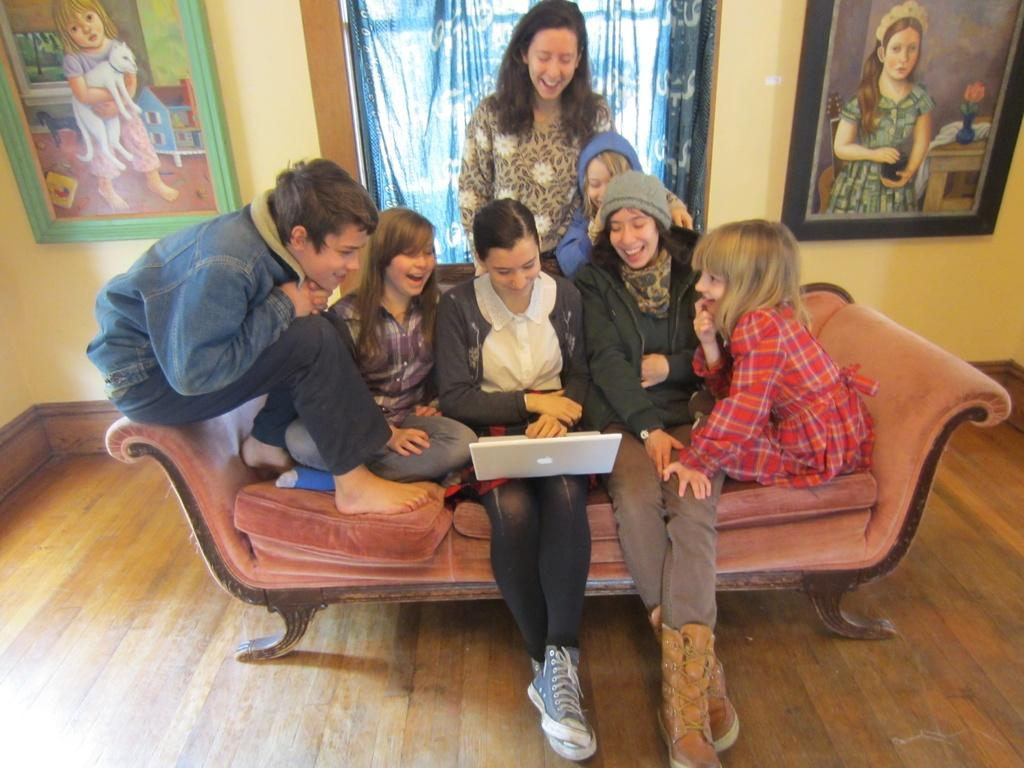Who or what is the focus of the people in the image? The people in the image are looking towards a laptop. What can be seen in the background of the image? There is a window and photo frames in the background of the image. What type of pen is the person wearing on their shirt in the image? There is no pen or shirt visible on any person in the image. 